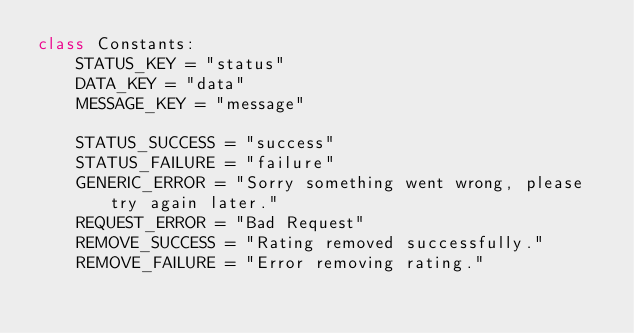Convert code to text. <code><loc_0><loc_0><loc_500><loc_500><_Python_>class Constants:
    STATUS_KEY = "status"
    DATA_KEY = "data"
    MESSAGE_KEY = "message"

    STATUS_SUCCESS = "success"
    STATUS_FAILURE = "failure"
    GENERIC_ERROR = "Sorry something went wrong, please try again later."
    REQUEST_ERROR = "Bad Request"
    REMOVE_SUCCESS = "Rating removed successfully."
    REMOVE_FAILURE = "Error removing rating."

</code> 